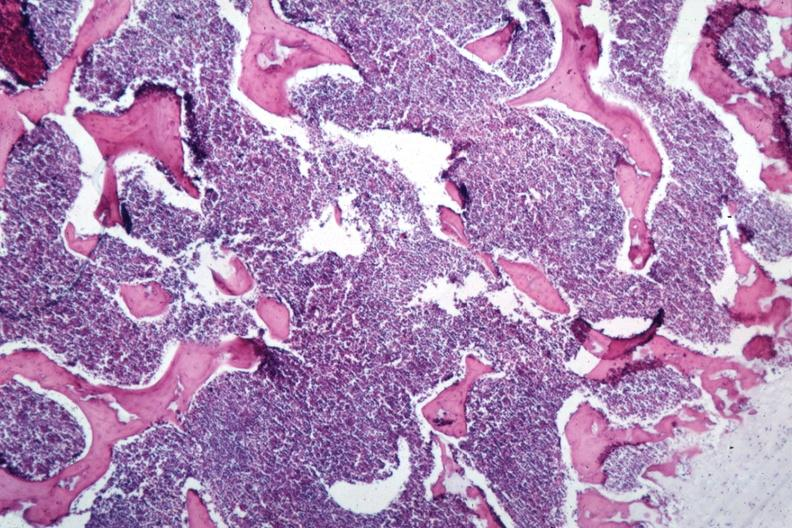s bone marrow present?
Answer the question using a single word or phrase. Yes 